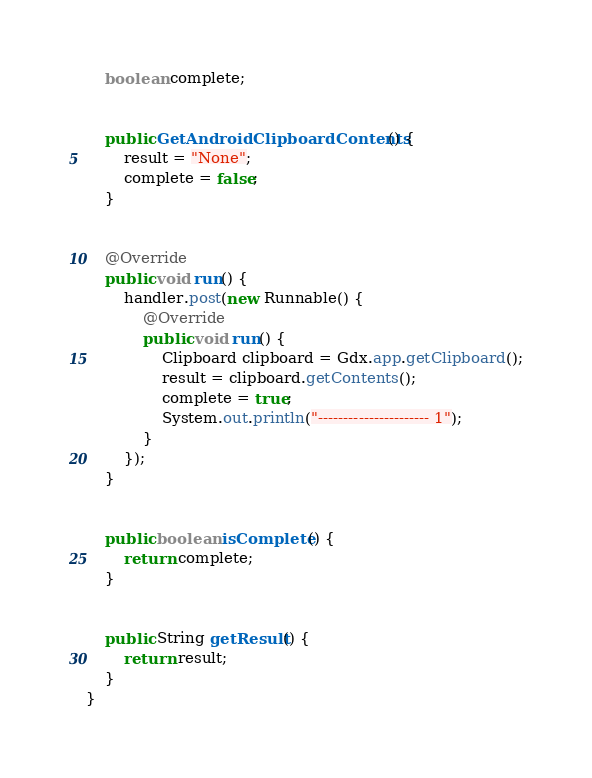Convert code to text. <code><loc_0><loc_0><loc_500><loc_500><_Java_>    boolean complete;


    public GetAndroidClipboardContents() {
        result = "None";
        complete = false;
    }


    @Override
    public void run() {
        handler.post(new Runnable() {
            @Override
            public void run() {
                Clipboard clipboard = Gdx.app.getClipboard();
                result = clipboard.getContents();
                complete = true;
                System.out.println("---------------------- 1");
            }
        });
    }


    public boolean isComplete() {
        return complete;
    }


    public String getResult() {
        return result;
    }
}
</code> 